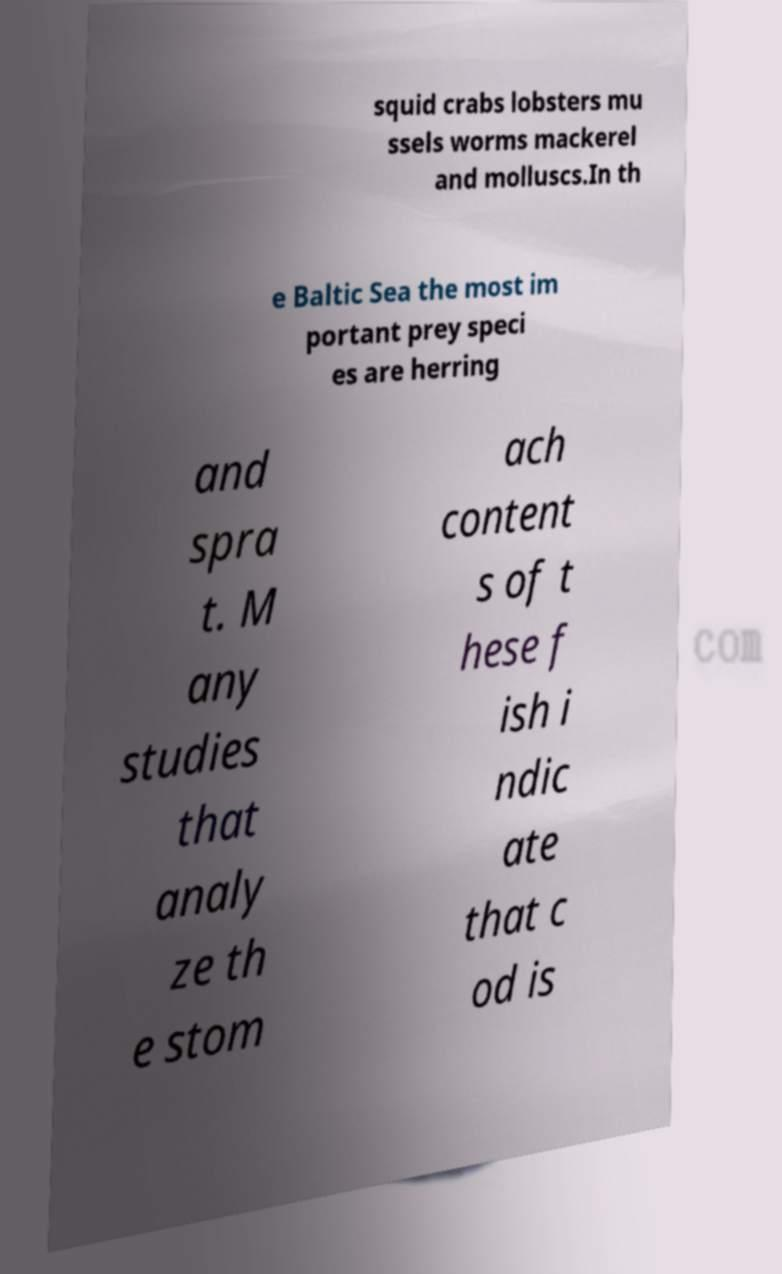Can you read and provide the text displayed in the image?This photo seems to have some interesting text. Can you extract and type it out for me? squid crabs lobsters mu ssels worms mackerel and molluscs.In th e Baltic Sea the most im portant prey speci es are herring and spra t. M any studies that analy ze th e stom ach content s of t hese f ish i ndic ate that c od is 